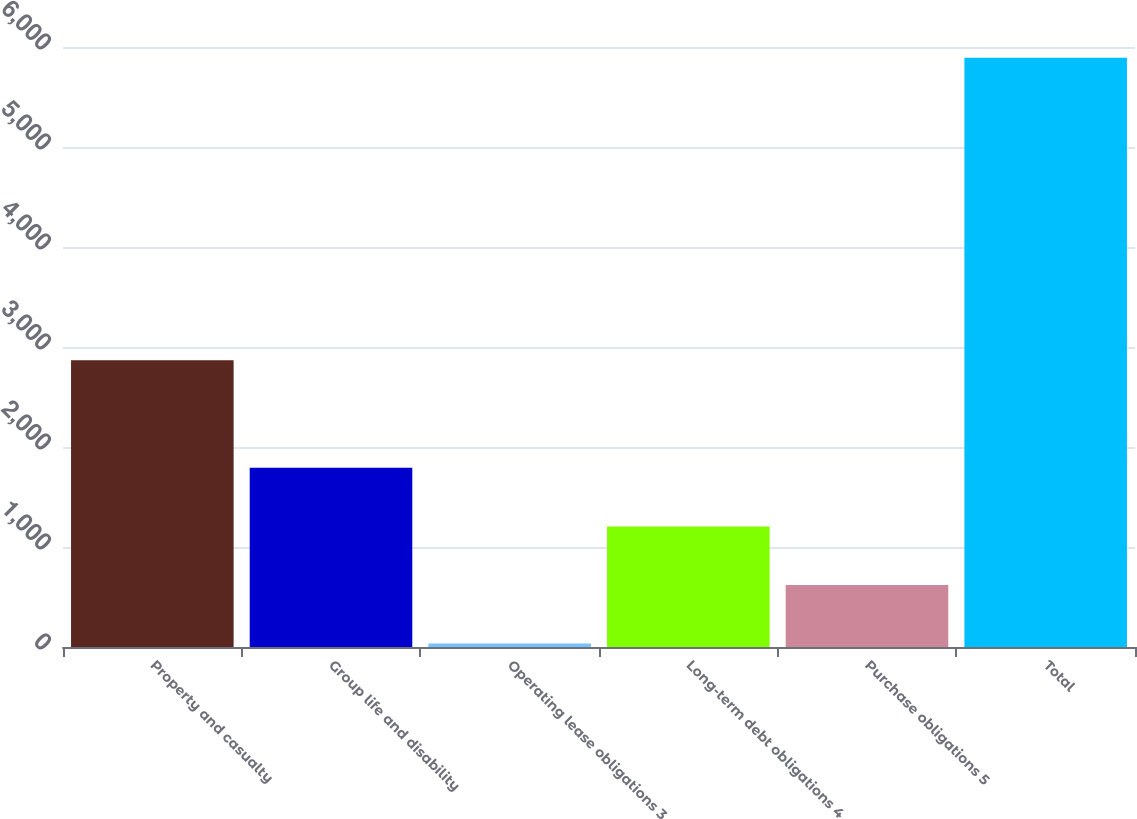Convert chart. <chart><loc_0><loc_0><loc_500><loc_500><bar_chart><fcel>Property and casualty<fcel>Group life and disability<fcel>Operating lease obligations 3<fcel>Long-term debt obligations 4<fcel>Purchase obligations 5<fcel>Total<nl><fcel>2868<fcel>1791.7<fcel>34<fcel>1205.8<fcel>619.9<fcel>5893<nl></chart> 